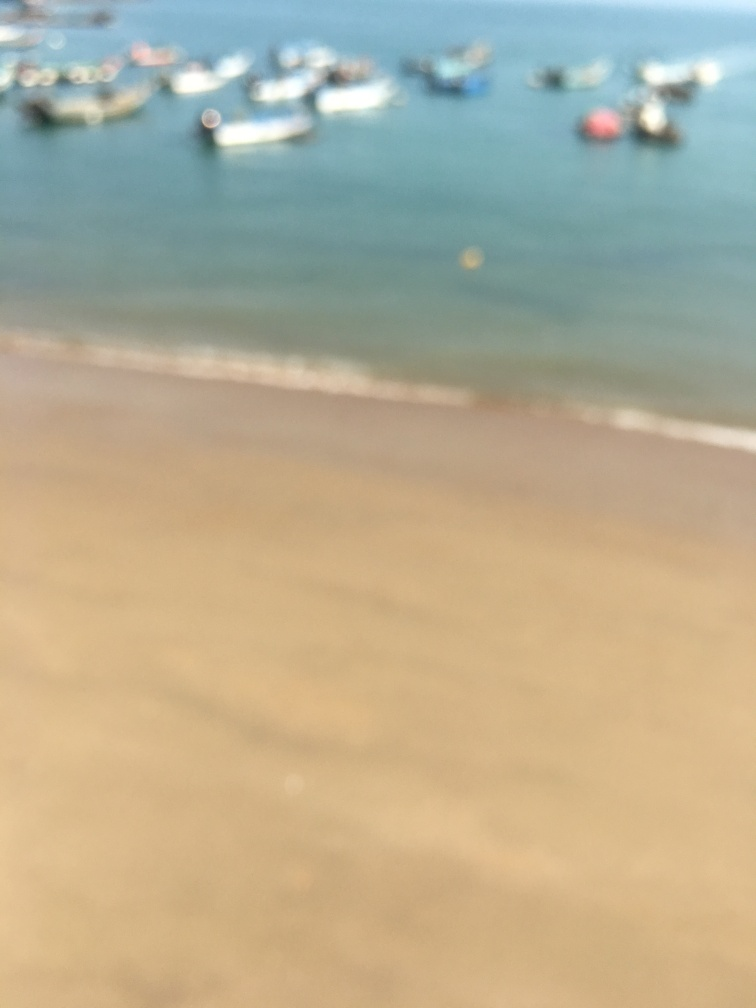If this image was in clear focus, what details might you expect to see? If the image was clear, we might see the distinct outlines of boats, possibly some with fishermen or tourists aboard. The texture of the sand on the beach, waves cascading onto the shore, and the reflections in the water would also be visible. The vibrant colors of the ocean and the boats would likely stand out, adding to the scene's vibrancy. 